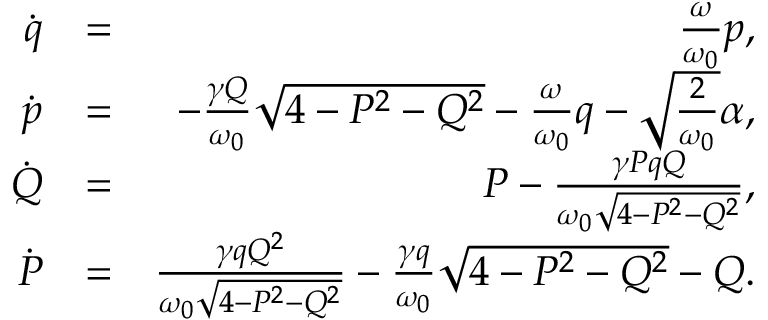<formula> <loc_0><loc_0><loc_500><loc_500>\begin{array} { r l r } { \dot { q } } & { = } & { \frac { \omega } { \omega _ { 0 } } p , } \\ { \dot { p } } & { = } & { - \frac { \gamma Q } { \omega _ { 0 } } \sqrt { 4 - P ^ { 2 } - Q ^ { 2 } } - \frac { \omega } { \omega _ { 0 } } q - \sqrt { \frac { 2 } { \omega _ { 0 } } } \alpha , } \\ { \dot { Q } } & { = } & { P - \frac { \gamma P q Q } { \omega _ { 0 } \sqrt { 4 - P ^ { 2 } - Q ^ { 2 } } } , } \\ { \dot { P } } & { = } & { \frac { \gamma q Q ^ { 2 } } { \omega _ { 0 } \sqrt { 4 - P ^ { 2 } - Q ^ { 2 } } } - \frac { \gamma q } { \omega _ { 0 } } \sqrt { 4 - P ^ { 2 } - Q ^ { 2 } } - Q . } \end{array}</formula> 